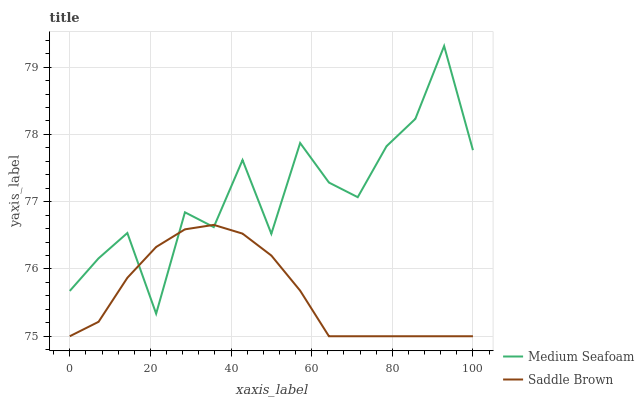Does Saddle Brown have the minimum area under the curve?
Answer yes or no. Yes. Does Medium Seafoam have the maximum area under the curve?
Answer yes or no. Yes. Does Saddle Brown have the maximum area under the curve?
Answer yes or no. No. Is Saddle Brown the smoothest?
Answer yes or no. Yes. Is Medium Seafoam the roughest?
Answer yes or no. Yes. Is Saddle Brown the roughest?
Answer yes or no. No. Does Saddle Brown have the lowest value?
Answer yes or no. Yes. Does Medium Seafoam have the highest value?
Answer yes or no. Yes. Does Saddle Brown have the highest value?
Answer yes or no. No. Does Saddle Brown intersect Medium Seafoam?
Answer yes or no. Yes. Is Saddle Brown less than Medium Seafoam?
Answer yes or no. No. Is Saddle Brown greater than Medium Seafoam?
Answer yes or no. No. 